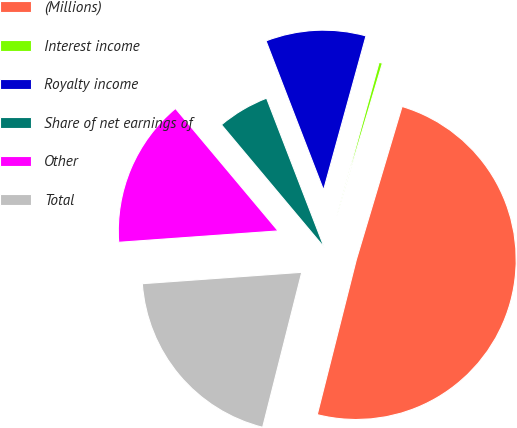Convert chart. <chart><loc_0><loc_0><loc_500><loc_500><pie_chart><fcel>(Millions)<fcel>Interest income<fcel>Royalty income<fcel>Share of net earnings of<fcel>Other<fcel>Total<nl><fcel>49.31%<fcel>0.34%<fcel>10.14%<fcel>5.24%<fcel>15.03%<fcel>19.93%<nl></chart> 